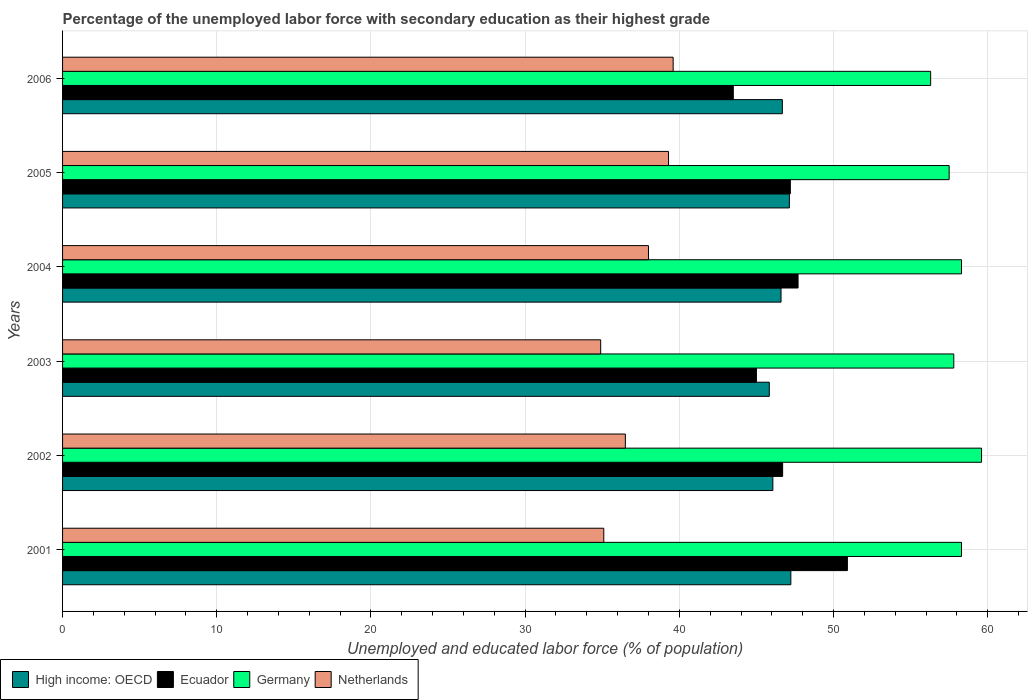How many groups of bars are there?
Offer a very short reply. 6. How many bars are there on the 6th tick from the top?
Your answer should be very brief. 4. What is the label of the 3rd group of bars from the top?
Your answer should be compact. 2004. In how many cases, is the number of bars for a given year not equal to the number of legend labels?
Provide a succinct answer. 0. What is the percentage of the unemployed labor force with secondary education in Ecuador in 2001?
Offer a very short reply. 50.9. Across all years, what is the maximum percentage of the unemployed labor force with secondary education in Netherlands?
Keep it short and to the point. 39.6. Across all years, what is the minimum percentage of the unemployed labor force with secondary education in Germany?
Keep it short and to the point. 56.3. What is the total percentage of the unemployed labor force with secondary education in High income: OECD in the graph?
Keep it short and to the point. 279.55. What is the difference between the percentage of the unemployed labor force with secondary education in Netherlands in 2005 and that in 2006?
Keep it short and to the point. -0.3. What is the difference between the percentage of the unemployed labor force with secondary education in Ecuador in 2004 and the percentage of the unemployed labor force with secondary education in Germany in 2003?
Your response must be concise. -10.1. What is the average percentage of the unemployed labor force with secondary education in High income: OECD per year?
Provide a short and direct response. 46.59. In the year 2003, what is the difference between the percentage of the unemployed labor force with secondary education in Ecuador and percentage of the unemployed labor force with secondary education in High income: OECD?
Your response must be concise. -0.84. In how many years, is the percentage of the unemployed labor force with secondary education in High income: OECD greater than 40 %?
Offer a very short reply. 6. What is the ratio of the percentage of the unemployed labor force with secondary education in Germany in 2001 to that in 2003?
Offer a terse response. 1.01. Is the difference between the percentage of the unemployed labor force with secondary education in Ecuador in 2002 and 2006 greater than the difference between the percentage of the unemployed labor force with secondary education in High income: OECD in 2002 and 2006?
Provide a short and direct response. Yes. What is the difference between the highest and the second highest percentage of the unemployed labor force with secondary education in Netherlands?
Your response must be concise. 0.3. What is the difference between the highest and the lowest percentage of the unemployed labor force with secondary education in Germany?
Offer a very short reply. 3.3. In how many years, is the percentage of the unemployed labor force with secondary education in High income: OECD greater than the average percentage of the unemployed labor force with secondary education in High income: OECD taken over all years?
Provide a succinct answer. 4. Is the sum of the percentage of the unemployed labor force with secondary education in High income: OECD in 2001 and 2005 greater than the maximum percentage of the unemployed labor force with secondary education in Netherlands across all years?
Your response must be concise. Yes. Is it the case that in every year, the sum of the percentage of the unemployed labor force with secondary education in Germany and percentage of the unemployed labor force with secondary education in Ecuador is greater than the sum of percentage of the unemployed labor force with secondary education in Netherlands and percentage of the unemployed labor force with secondary education in High income: OECD?
Ensure brevity in your answer.  Yes. What does the 3rd bar from the top in 2002 represents?
Offer a very short reply. Ecuador. Are all the bars in the graph horizontal?
Your response must be concise. Yes. How many years are there in the graph?
Your response must be concise. 6. Does the graph contain any zero values?
Make the answer very short. No. Where does the legend appear in the graph?
Keep it short and to the point. Bottom left. What is the title of the graph?
Make the answer very short. Percentage of the unemployed labor force with secondary education as their highest grade. What is the label or title of the X-axis?
Provide a short and direct response. Unemployed and educated labor force (% of population). What is the label or title of the Y-axis?
Offer a very short reply. Years. What is the Unemployed and educated labor force (% of population) of High income: OECD in 2001?
Offer a terse response. 47.23. What is the Unemployed and educated labor force (% of population) of Ecuador in 2001?
Offer a terse response. 50.9. What is the Unemployed and educated labor force (% of population) of Germany in 2001?
Keep it short and to the point. 58.3. What is the Unemployed and educated labor force (% of population) of Netherlands in 2001?
Your answer should be compact. 35.1. What is the Unemployed and educated labor force (% of population) in High income: OECD in 2002?
Make the answer very short. 46.07. What is the Unemployed and educated labor force (% of population) in Ecuador in 2002?
Provide a short and direct response. 46.7. What is the Unemployed and educated labor force (% of population) in Germany in 2002?
Your response must be concise. 59.6. What is the Unemployed and educated labor force (% of population) in Netherlands in 2002?
Give a very brief answer. 36.5. What is the Unemployed and educated labor force (% of population) in High income: OECD in 2003?
Ensure brevity in your answer.  45.84. What is the Unemployed and educated labor force (% of population) in Ecuador in 2003?
Provide a succinct answer. 45. What is the Unemployed and educated labor force (% of population) in Germany in 2003?
Offer a terse response. 57.8. What is the Unemployed and educated labor force (% of population) of Netherlands in 2003?
Your answer should be very brief. 34.9. What is the Unemployed and educated labor force (% of population) in High income: OECD in 2004?
Your answer should be very brief. 46.6. What is the Unemployed and educated labor force (% of population) in Ecuador in 2004?
Your answer should be compact. 47.7. What is the Unemployed and educated labor force (% of population) in Germany in 2004?
Your answer should be compact. 58.3. What is the Unemployed and educated labor force (% of population) in Netherlands in 2004?
Offer a very short reply. 38. What is the Unemployed and educated labor force (% of population) of High income: OECD in 2005?
Offer a terse response. 47.14. What is the Unemployed and educated labor force (% of population) in Ecuador in 2005?
Give a very brief answer. 47.2. What is the Unemployed and educated labor force (% of population) in Germany in 2005?
Your response must be concise. 57.5. What is the Unemployed and educated labor force (% of population) in Netherlands in 2005?
Keep it short and to the point. 39.3. What is the Unemployed and educated labor force (% of population) of High income: OECD in 2006?
Your answer should be compact. 46.68. What is the Unemployed and educated labor force (% of population) in Ecuador in 2006?
Ensure brevity in your answer.  43.5. What is the Unemployed and educated labor force (% of population) in Germany in 2006?
Give a very brief answer. 56.3. What is the Unemployed and educated labor force (% of population) of Netherlands in 2006?
Provide a short and direct response. 39.6. Across all years, what is the maximum Unemployed and educated labor force (% of population) of High income: OECD?
Give a very brief answer. 47.23. Across all years, what is the maximum Unemployed and educated labor force (% of population) in Ecuador?
Offer a very short reply. 50.9. Across all years, what is the maximum Unemployed and educated labor force (% of population) of Germany?
Provide a short and direct response. 59.6. Across all years, what is the maximum Unemployed and educated labor force (% of population) in Netherlands?
Provide a short and direct response. 39.6. Across all years, what is the minimum Unemployed and educated labor force (% of population) of High income: OECD?
Ensure brevity in your answer.  45.84. Across all years, what is the minimum Unemployed and educated labor force (% of population) of Ecuador?
Your answer should be compact. 43.5. Across all years, what is the minimum Unemployed and educated labor force (% of population) in Germany?
Make the answer very short. 56.3. Across all years, what is the minimum Unemployed and educated labor force (% of population) in Netherlands?
Ensure brevity in your answer.  34.9. What is the total Unemployed and educated labor force (% of population) of High income: OECD in the graph?
Your response must be concise. 279.55. What is the total Unemployed and educated labor force (% of population) of Ecuador in the graph?
Your response must be concise. 281. What is the total Unemployed and educated labor force (% of population) in Germany in the graph?
Keep it short and to the point. 347.8. What is the total Unemployed and educated labor force (% of population) in Netherlands in the graph?
Your response must be concise. 223.4. What is the difference between the Unemployed and educated labor force (% of population) of High income: OECD in 2001 and that in 2002?
Offer a very short reply. 1.17. What is the difference between the Unemployed and educated labor force (% of population) in Germany in 2001 and that in 2002?
Your answer should be compact. -1.3. What is the difference between the Unemployed and educated labor force (% of population) of High income: OECD in 2001 and that in 2003?
Keep it short and to the point. 1.4. What is the difference between the Unemployed and educated labor force (% of population) of Germany in 2001 and that in 2003?
Provide a short and direct response. 0.5. What is the difference between the Unemployed and educated labor force (% of population) of High income: OECD in 2001 and that in 2004?
Ensure brevity in your answer.  0.64. What is the difference between the Unemployed and educated labor force (% of population) of Netherlands in 2001 and that in 2004?
Provide a short and direct response. -2.9. What is the difference between the Unemployed and educated labor force (% of population) in High income: OECD in 2001 and that in 2005?
Provide a succinct answer. 0.1. What is the difference between the Unemployed and educated labor force (% of population) of Netherlands in 2001 and that in 2005?
Give a very brief answer. -4.2. What is the difference between the Unemployed and educated labor force (% of population) in High income: OECD in 2001 and that in 2006?
Ensure brevity in your answer.  0.55. What is the difference between the Unemployed and educated labor force (% of population) of Germany in 2001 and that in 2006?
Offer a very short reply. 2. What is the difference between the Unemployed and educated labor force (% of population) in High income: OECD in 2002 and that in 2003?
Offer a terse response. 0.23. What is the difference between the Unemployed and educated labor force (% of population) of High income: OECD in 2002 and that in 2004?
Give a very brief answer. -0.53. What is the difference between the Unemployed and educated labor force (% of population) of Germany in 2002 and that in 2004?
Keep it short and to the point. 1.3. What is the difference between the Unemployed and educated labor force (% of population) of Netherlands in 2002 and that in 2004?
Your response must be concise. -1.5. What is the difference between the Unemployed and educated labor force (% of population) of High income: OECD in 2002 and that in 2005?
Provide a short and direct response. -1.07. What is the difference between the Unemployed and educated labor force (% of population) in Ecuador in 2002 and that in 2005?
Make the answer very short. -0.5. What is the difference between the Unemployed and educated labor force (% of population) in Germany in 2002 and that in 2005?
Give a very brief answer. 2.1. What is the difference between the Unemployed and educated labor force (% of population) in Netherlands in 2002 and that in 2005?
Offer a terse response. -2.8. What is the difference between the Unemployed and educated labor force (% of population) in High income: OECD in 2002 and that in 2006?
Your answer should be very brief. -0.62. What is the difference between the Unemployed and educated labor force (% of population) of Ecuador in 2002 and that in 2006?
Your response must be concise. 3.2. What is the difference between the Unemployed and educated labor force (% of population) in High income: OECD in 2003 and that in 2004?
Offer a terse response. -0.76. What is the difference between the Unemployed and educated labor force (% of population) in Germany in 2003 and that in 2004?
Provide a succinct answer. -0.5. What is the difference between the Unemployed and educated labor force (% of population) in High income: OECD in 2003 and that in 2005?
Provide a succinct answer. -1.3. What is the difference between the Unemployed and educated labor force (% of population) in Ecuador in 2003 and that in 2005?
Provide a succinct answer. -2.2. What is the difference between the Unemployed and educated labor force (% of population) of Germany in 2003 and that in 2005?
Provide a short and direct response. 0.3. What is the difference between the Unemployed and educated labor force (% of population) of High income: OECD in 2003 and that in 2006?
Keep it short and to the point. -0.85. What is the difference between the Unemployed and educated labor force (% of population) in Netherlands in 2003 and that in 2006?
Your answer should be compact. -4.7. What is the difference between the Unemployed and educated labor force (% of population) in High income: OECD in 2004 and that in 2005?
Offer a very short reply. -0.54. What is the difference between the Unemployed and educated labor force (% of population) of Netherlands in 2004 and that in 2005?
Provide a succinct answer. -1.3. What is the difference between the Unemployed and educated labor force (% of population) in High income: OECD in 2004 and that in 2006?
Provide a short and direct response. -0.09. What is the difference between the Unemployed and educated labor force (% of population) of Netherlands in 2004 and that in 2006?
Offer a very short reply. -1.6. What is the difference between the Unemployed and educated labor force (% of population) in High income: OECD in 2005 and that in 2006?
Your response must be concise. 0.46. What is the difference between the Unemployed and educated labor force (% of population) of Ecuador in 2005 and that in 2006?
Offer a very short reply. 3.7. What is the difference between the Unemployed and educated labor force (% of population) of Germany in 2005 and that in 2006?
Ensure brevity in your answer.  1.2. What is the difference between the Unemployed and educated labor force (% of population) in Netherlands in 2005 and that in 2006?
Your answer should be very brief. -0.3. What is the difference between the Unemployed and educated labor force (% of population) of High income: OECD in 2001 and the Unemployed and educated labor force (% of population) of Ecuador in 2002?
Give a very brief answer. 0.53. What is the difference between the Unemployed and educated labor force (% of population) of High income: OECD in 2001 and the Unemployed and educated labor force (% of population) of Germany in 2002?
Your response must be concise. -12.37. What is the difference between the Unemployed and educated labor force (% of population) in High income: OECD in 2001 and the Unemployed and educated labor force (% of population) in Netherlands in 2002?
Provide a short and direct response. 10.73. What is the difference between the Unemployed and educated labor force (% of population) in Ecuador in 2001 and the Unemployed and educated labor force (% of population) in Germany in 2002?
Provide a succinct answer. -8.7. What is the difference between the Unemployed and educated labor force (% of population) of Ecuador in 2001 and the Unemployed and educated labor force (% of population) of Netherlands in 2002?
Your answer should be compact. 14.4. What is the difference between the Unemployed and educated labor force (% of population) in Germany in 2001 and the Unemployed and educated labor force (% of population) in Netherlands in 2002?
Your response must be concise. 21.8. What is the difference between the Unemployed and educated labor force (% of population) of High income: OECD in 2001 and the Unemployed and educated labor force (% of population) of Ecuador in 2003?
Make the answer very short. 2.23. What is the difference between the Unemployed and educated labor force (% of population) of High income: OECD in 2001 and the Unemployed and educated labor force (% of population) of Germany in 2003?
Offer a very short reply. -10.57. What is the difference between the Unemployed and educated labor force (% of population) of High income: OECD in 2001 and the Unemployed and educated labor force (% of population) of Netherlands in 2003?
Make the answer very short. 12.33. What is the difference between the Unemployed and educated labor force (% of population) of Germany in 2001 and the Unemployed and educated labor force (% of population) of Netherlands in 2003?
Your answer should be compact. 23.4. What is the difference between the Unemployed and educated labor force (% of population) of High income: OECD in 2001 and the Unemployed and educated labor force (% of population) of Ecuador in 2004?
Your answer should be very brief. -0.47. What is the difference between the Unemployed and educated labor force (% of population) in High income: OECD in 2001 and the Unemployed and educated labor force (% of population) in Germany in 2004?
Give a very brief answer. -11.07. What is the difference between the Unemployed and educated labor force (% of population) in High income: OECD in 2001 and the Unemployed and educated labor force (% of population) in Netherlands in 2004?
Offer a very short reply. 9.23. What is the difference between the Unemployed and educated labor force (% of population) in Ecuador in 2001 and the Unemployed and educated labor force (% of population) in Netherlands in 2004?
Your answer should be compact. 12.9. What is the difference between the Unemployed and educated labor force (% of population) of Germany in 2001 and the Unemployed and educated labor force (% of population) of Netherlands in 2004?
Ensure brevity in your answer.  20.3. What is the difference between the Unemployed and educated labor force (% of population) of High income: OECD in 2001 and the Unemployed and educated labor force (% of population) of Ecuador in 2005?
Provide a short and direct response. 0.03. What is the difference between the Unemployed and educated labor force (% of population) of High income: OECD in 2001 and the Unemployed and educated labor force (% of population) of Germany in 2005?
Make the answer very short. -10.27. What is the difference between the Unemployed and educated labor force (% of population) of High income: OECD in 2001 and the Unemployed and educated labor force (% of population) of Netherlands in 2005?
Provide a short and direct response. 7.93. What is the difference between the Unemployed and educated labor force (% of population) of Ecuador in 2001 and the Unemployed and educated labor force (% of population) of Netherlands in 2005?
Your answer should be compact. 11.6. What is the difference between the Unemployed and educated labor force (% of population) of Germany in 2001 and the Unemployed and educated labor force (% of population) of Netherlands in 2005?
Your answer should be very brief. 19. What is the difference between the Unemployed and educated labor force (% of population) of High income: OECD in 2001 and the Unemployed and educated labor force (% of population) of Ecuador in 2006?
Offer a very short reply. 3.73. What is the difference between the Unemployed and educated labor force (% of population) in High income: OECD in 2001 and the Unemployed and educated labor force (% of population) in Germany in 2006?
Your answer should be very brief. -9.07. What is the difference between the Unemployed and educated labor force (% of population) of High income: OECD in 2001 and the Unemployed and educated labor force (% of population) of Netherlands in 2006?
Provide a short and direct response. 7.63. What is the difference between the Unemployed and educated labor force (% of population) in Ecuador in 2001 and the Unemployed and educated labor force (% of population) in Netherlands in 2006?
Ensure brevity in your answer.  11.3. What is the difference between the Unemployed and educated labor force (% of population) in High income: OECD in 2002 and the Unemployed and educated labor force (% of population) in Ecuador in 2003?
Provide a short and direct response. 1.07. What is the difference between the Unemployed and educated labor force (% of population) of High income: OECD in 2002 and the Unemployed and educated labor force (% of population) of Germany in 2003?
Your answer should be very brief. -11.73. What is the difference between the Unemployed and educated labor force (% of population) of High income: OECD in 2002 and the Unemployed and educated labor force (% of population) of Netherlands in 2003?
Ensure brevity in your answer.  11.17. What is the difference between the Unemployed and educated labor force (% of population) of Germany in 2002 and the Unemployed and educated labor force (% of population) of Netherlands in 2003?
Ensure brevity in your answer.  24.7. What is the difference between the Unemployed and educated labor force (% of population) in High income: OECD in 2002 and the Unemployed and educated labor force (% of population) in Ecuador in 2004?
Provide a short and direct response. -1.63. What is the difference between the Unemployed and educated labor force (% of population) in High income: OECD in 2002 and the Unemployed and educated labor force (% of population) in Germany in 2004?
Your answer should be compact. -12.23. What is the difference between the Unemployed and educated labor force (% of population) of High income: OECD in 2002 and the Unemployed and educated labor force (% of population) of Netherlands in 2004?
Offer a terse response. 8.07. What is the difference between the Unemployed and educated labor force (% of population) in Ecuador in 2002 and the Unemployed and educated labor force (% of population) in Germany in 2004?
Provide a short and direct response. -11.6. What is the difference between the Unemployed and educated labor force (% of population) of Ecuador in 2002 and the Unemployed and educated labor force (% of population) of Netherlands in 2004?
Your answer should be very brief. 8.7. What is the difference between the Unemployed and educated labor force (% of population) in Germany in 2002 and the Unemployed and educated labor force (% of population) in Netherlands in 2004?
Make the answer very short. 21.6. What is the difference between the Unemployed and educated labor force (% of population) of High income: OECD in 2002 and the Unemployed and educated labor force (% of population) of Ecuador in 2005?
Offer a very short reply. -1.13. What is the difference between the Unemployed and educated labor force (% of population) in High income: OECD in 2002 and the Unemployed and educated labor force (% of population) in Germany in 2005?
Provide a short and direct response. -11.43. What is the difference between the Unemployed and educated labor force (% of population) in High income: OECD in 2002 and the Unemployed and educated labor force (% of population) in Netherlands in 2005?
Your response must be concise. 6.77. What is the difference between the Unemployed and educated labor force (% of population) of Germany in 2002 and the Unemployed and educated labor force (% of population) of Netherlands in 2005?
Ensure brevity in your answer.  20.3. What is the difference between the Unemployed and educated labor force (% of population) in High income: OECD in 2002 and the Unemployed and educated labor force (% of population) in Ecuador in 2006?
Offer a very short reply. 2.57. What is the difference between the Unemployed and educated labor force (% of population) in High income: OECD in 2002 and the Unemployed and educated labor force (% of population) in Germany in 2006?
Keep it short and to the point. -10.23. What is the difference between the Unemployed and educated labor force (% of population) in High income: OECD in 2002 and the Unemployed and educated labor force (% of population) in Netherlands in 2006?
Give a very brief answer. 6.47. What is the difference between the Unemployed and educated labor force (% of population) of Ecuador in 2002 and the Unemployed and educated labor force (% of population) of Netherlands in 2006?
Your answer should be very brief. 7.1. What is the difference between the Unemployed and educated labor force (% of population) in High income: OECD in 2003 and the Unemployed and educated labor force (% of population) in Ecuador in 2004?
Give a very brief answer. -1.86. What is the difference between the Unemployed and educated labor force (% of population) of High income: OECD in 2003 and the Unemployed and educated labor force (% of population) of Germany in 2004?
Offer a very short reply. -12.46. What is the difference between the Unemployed and educated labor force (% of population) of High income: OECD in 2003 and the Unemployed and educated labor force (% of population) of Netherlands in 2004?
Provide a short and direct response. 7.84. What is the difference between the Unemployed and educated labor force (% of population) in Ecuador in 2003 and the Unemployed and educated labor force (% of population) in Netherlands in 2004?
Offer a terse response. 7. What is the difference between the Unemployed and educated labor force (% of population) of Germany in 2003 and the Unemployed and educated labor force (% of population) of Netherlands in 2004?
Offer a terse response. 19.8. What is the difference between the Unemployed and educated labor force (% of population) in High income: OECD in 2003 and the Unemployed and educated labor force (% of population) in Ecuador in 2005?
Your answer should be compact. -1.36. What is the difference between the Unemployed and educated labor force (% of population) in High income: OECD in 2003 and the Unemployed and educated labor force (% of population) in Germany in 2005?
Make the answer very short. -11.66. What is the difference between the Unemployed and educated labor force (% of population) in High income: OECD in 2003 and the Unemployed and educated labor force (% of population) in Netherlands in 2005?
Provide a short and direct response. 6.54. What is the difference between the Unemployed and educated labor force (% of population) of Ecuador in 2003 and the Unemployed and educated labor force (% of population) of Germany in 2005?
Offer a terse response. -12.5. What is the difference between the Unemployed and educated labor force (% of population) of High income: OECD in 2003 and the Unemployed and educated labor force (% of population) of Ecuador in 2006?
Provide a succinct answer. 2.34. What is the difference between the Unemployed and educated labor force (% of population) in High income: OECD in 2003 and the Unemployed and educated labor force (% of population) in Germany in 2006?
Provide a short and direct response. -10.46. What is the difference between the Unemployed and educated labor force (% of population) in High income: OECD in 2003 and the Unemployed and educated labor force (% of population) in Netherlands in 2006?
Give a very brief answer. 6.24. What is the difference between the Unemployed and educated labor force (% of population) in Ecuador in 2003 and the Unemployed and educated labor force (% of population) in Germany in 2006?
Provide a succinct answer. -11.3. What is the difference between the Unemployed and educated labor force (% of population) in Germany in 2003 and the Unemployed and educated labor force (% of population) in Netherlands in 2006?
Offer a very short reply. 18.2. What is the difference between the Unemployed and educated labor force (% of population) in High income: OECD in 2004 and the Unemployed and educated labor force (% of population) in Ecuador in 2005?
Provide a succinct answer. -0.6. What is the difference between the Unemployed and educated labor force (% of population) of High income: OECD in 2004 and the Unemployed and educated labor force (% of population) of Germany in 2005?
Your response must be concise. -10.9. What is the difference between the Unemployed and educated labor force (% of population) of High income: OECD in 2004 and the Unemployed and educated labor force (% of population) of Netherlands in 2005?
Give a very brief answer. 7.3. What is the difference between the Unemployed and educated labor force (% of population) of Ecuador in 2004 and the Unemployed and educated labor force (% of population) of Netherlands in 2005?
Provide a succinct answer. 8.4. What is the difference between the Unemployed and educated labor force (% of population) in Germany in 2004 and the Unemployed and educated labor force (% of population) in Netherlands in 2005?
Give a very brief answer. 19. What is the difference between the Unemployed and educated labor force (% of population) in High income: OECD in 2004 and the Unemployed and educated labor force (% of population) in Ecuador in 2006?
Your response must be concise. 3.1. What is the difference between the Unemployed and educated labor force (% of population) of High income: OECD in 2004 and the Unemployed and educated labor force (% of population) of Germany in 2006?
Your answer should be very brief. -9.7. What is the difference between the Unemployed and educated labor force (% of population) of High income: OECD in 2004 and the Unemployed and educated labor force (% of population) of Netherlands in 2006?
Make the answer very short. 7. What is the difference between the Unemployed and educated labor force (% of population) in Ecuador in 2004 and the Unemployed and educated labor force (% of population) in Germany in 2006?
Offer a very short reply. -8.6. What is the difference between the Unemployed and educated labor force (% of population) of Ecuador in 2004 and the Unemployed and educated labor force (% of population) of Netherlands in 2006?
Make the answer very short. 8.1. What is the difference between the Unemployed and educated labor force (% of population) of Germany in 2004 and the Unemployed and educated labor force (% of population) of Netherlands in 2006?
Keep it short and to the point. 18.7. What is the difference between the Unemployed and educated labor force (% of population) of High income: OECD in 2005 and the Unemployed and educated labor force (% of population) of Ecuador in 2006?
Offer a terse response. 3.64. What is the difference between the Unemployed and educated labor force (% of population) of High income: OECD in 2005 and the Unemployed and educated labor force (% of population) of Germany in 2006?
Keep it short and to the point. -9.16. What is the difference between the Unemployed and educated labor force (% of population) of High income: OECD in 2005 and the Unemployed and educated labor force (% of population) of Netherlands in 2006?
Your response must be concise. 7.54. What is the average Unemployed and educated labor force (% of population) in High income: OECD per year?
Give a very brief answer. 46.59. What is the average Unemployed and educated labor force (% of population) of Ecuador per year?
Your answer should be very brief. 46.83. What is the average Unemployed and educated labor force (% of population) of Germany per year?
Keep it short and to the point. 57.97. What is the average Unemployed and educated labor force (% of population) in Netherlands per year?
Your answer should be very brief. 37.23. In the year 2001, what is the difference between the Unemployed and educated labor force (% of population) in High income: OECD and Unemployed and educated labor force (% of population) in Ecuador?
Your answer should be very brief. -3.67. In the year 2001, what is the difference between the Unemployed and educated labor force (% of population) of High income: OECD and Unemployed and educated labor force (% of population) of Germany?
Your response must be concise. -11.07. In the year 2001, what is the difference between the Unemployed and educated labor force (% of population) in High income: OECD and Unemployed and educated labor force (% of population) in Netherlands?
Your answer should be compact. 12.13. In the year 2001, what is the difference between the Unemployed and educated labor force (% of population) in Germany and Unemployed and educated labor force (% of population) in Netherlands?
Make the answer very short. 23.2. In the year 2002, what is the difference between the Unemployed and educated labor force (% of population) in High income: OECD and Unemployed and educated labor force (% of population) in Ecuador?
Give a very brief answer. -0.63. In the year 2002, what is the difference between the Unemployed and educated labor force (% of population) in High income: OECD and Unemployed and educated labor force (% of population) in Germany?
Your answer should be very brief. -13.53. In the year 2002, what is the difference between the Unemployed and educated labor force (% of population) of High income: OECD and Unemployed and educated labor force (% of population) of Netherlands?
Your answer should be compact. 9.57. In the year 2002, what is the difference between the Unemployed and educated labor force (% of population) of Ecuador and Unemployed and educated labor force (% of population) of Netherlands?
Your answer should be compact. 10.2. In the year 2002, what is the difference between the Unemployed and educated labor force (% of population) of Germany and Unemployed and educated labor force (% of population) of Netherlands?
Offer a terse response. 23.1. In the year 2003, what is the difference between the Unemployed and educated labor force (% of population) of High income: OECD and Unemployed and educated labor force (% of population) of Ecuador?
Provide a short and direct response. 0.84. In the year 2003, what is the difference between the Unemployed and educated labor force (% of population) in High income: OECD and Unemployed and educated labor force (% of population) in Germany?
Offer a terse response. -11.96. In the year 2003, what is the difference between the Unemployed and educated labor force (% of population) in High income: OECD and Unemployed and educated labor force (% of population) in Netherlands?
Provide a short and direct response. 10.94. In the year 2003, what is the difference between the Unemployed and educated labor force (% of population) of Ecuador and Unemployed and educated labor force (% of population) of Netherlands?
Make the answer very short. 10.1. In the year 2003, what is the difference between the Unemployed and educated labor force (% of population) in Germany and Unemployed and educated labor force (% of population) in Netherlands?
Ensure brevity in your answer.  22.9. In the year 2004, what is the difference between the Unemployed and educated labor force (% of population) of High income: OECD and Unemployed and educated labor force (% of population) of Ecuador?
Provide a short and direct response. -1.1. In the year 2004, what is the difference between the Unemployed and educated labor force (% of population) of High income: OECD and Unemployed and educated labor force (% of population) of Germany?
Offer a terse response. -11.7. In the year 2004, what is the difference between the Unemployed and educated labor force (% of population) of High income: OECD and Unemployed and educated labor force (% of population) of Netherlands?
Your answer should be very brief. 8.6. In the year 2004, what is the difference between the Unemployed and educated labor force (% of population) in Ecuador and Unemployed and educated labor force (% of population) in Netherlands?
Keep it short and to the point. 9.7. In the year 2004, what is the difference between the Unemployed and educated labor force (% of population) of Germany and Unemployed and educated labor force (% of population) of Netherlands?
Give a very brief answer. 20.3. In the year 2005, what is the difference between the Unemployed and educated labor force (% of population) of High income: OECD and Unemployed and educated labor force (% of population) of Ecuador?
Provide a succinct answer. -0.06. In the year 2005, what is the difference between the Unemployed and educated labor force (% of population) of High income: OECD and Unemployed and educated labor force (% of population) of Germany?
Your answer should be compact. -10.36. In the year 2005, what is the difference between the Unemployed and educated labor force (% of population) in High income: OECD and Unemployed and educated labor force (% of population) in Netherlands?
Ensure brevity in your answer.  7.84. In the year 2005, what is the difference between the Unemployed and educated labor force (% of population) of Ecuador and Unemployed and educated labor force (% of population) of Netherlands?
Give a very brief answer. 7.9. In the year 2005, what is the difference between the Unemployed and educated labor force (% of population) of Germany and Unemployed and educated labor force (% of population) of Netherlands?
Offer a very short reply. 18.2. In the year 2006, what is the difference between the Unemployed and educated labor force (% of population) in High income: OECD and Unemployed and educated labor force (% of population) in Ecuador?
Your response must be concise. 3.18. In the year 2006, what is the difference between the Unemployed and educated labor force (% of population) of High income: OECD and Unemployed and educated labor force (% of population) of Germany?
Make the answer very short. -9.62. In the year 2006, what is the difference between the Unemployed and educated labor force (% of population) in High income: OECD and Unemployed and educated labor force (% of population) in Netherlands?
Offer a very short reply. 7.08. In the year 2006, what is the difference between the Unemployed and educated labor force (% of population) of Ecuador and Unemployed and educated labor force (% of population) of Germany?
Make the answer very short. -12.8. In the year 2006, what is the difference between the Unemployed and educated labor force (% of population) of Ecuador and Unemployed and educated labor force (% of population) of Netherlands?
Keep it short and to the point. 3.9. In the year 2006, what is the difference between the Unemployed and educated labor force (% of population) of Germany and Unemployed and educated labor force (% of population) of Netherlands?
Offer a very short reply. 16.7. What is the ratio of the Unemployed and educated labor force (% of population) of High income: OECD in 2001 to that in 2002?
Your response must be concise. 1.03. What is the ratio of the Unemployed and educated labor force (% of population) in Ecuador in 2001 to that in 2002?
Provide a short and direct response. 1.09. What is the ratio of the Unemployed and educated labor force (% of population) of Germany in 2001 to that in 2002?
Your answer should be compact. 0.98. What is the ratio of the Unemployed and educated labor force (% of population) in Netherlands in 2001 to that in 2002?
Your answer should be compact. 0.96. What is the ratio of the Unemployed and educated labor force (% of population) of High income: OECD in 2001 to that in 2003?
Keep it short and to the point. 1.03. What is the ratio of the Unemployed and educated labor force (% of population) of Ecuador in 2001 to that in 2003?
Provide a short and direct response. 1.13. What is the ratio of the Unemployed and educated labor force (% of population) in Germany in 2001 to that in 2003?
Ensure brevity in your answer.  1.01. What is the ratio of the Unemployed and educated labor force (% of population) of Netherlands in 2001 to that in 2003?
Give a very brief answer. 1.01. What is the ratio of the Unemployed and educated labor force (% of population) of High income: OECD in 2001 to that in 2004?
Offer a very short reply. 1.01. What is the ratio of the Unemployed and educated labor force (% of population) of Ecuador in 2001 to that in 2004?
Offer a very short reply. 1.07. What is the ratio of the Unemployed and educated labor force (% of population) of Netherlands in 2001 to that in 2004?
Keep it short and to the point. 0.92. What is the ratio of the Unemployed and educated labor force (% of population) of High income: OECD in 2001 to that in 2005?
Provide a succinct answer. 1. What is the ratio of the Unemployed and educated labor force (% of population) of Ecuador in 2001 to that in 2005?
Offer a terse response. 1.08. What is the ratio of the Unemployed and educated labor force (% of population) in Germany in 2001 to that in 2005?
Offer a very short reply. 1.01. What is the ratio of the Unemployed and educated labor force (% of population) in Netherlands in 2001 to that in 2005?
Provide a short and direct response. 0.89. What is the ratio of the Unemployed and educated labor force (% of population) of High income: OECD in 2001 to that in 2006?
Give a very brief answer. 1.01. What is the ratio of the Unemployed and educated labor force (% of population) in Ecuador in 2001 to that in 2006?
Your answer should be very brief. 1.17. What is the ratio of the Unemployed and educated labor force (% of population) of Germany in 2001 to that in 2006?
Offer a very short reply. 1.04. What is the ratio of the Unemployed and educated labor force (% of population) of Netherlands in 2001 to that in 2006?
Give a very brief answer. 0.89. What is the ratio of the Unemployed and educated labor force (% of population) in Ecuador in 2002 to that in 2003?
Provide a succinct answer. 1.04. What is the ratio of the Unemployed and educated labor force (% of population) in Germany in 2002 to that in 2003?
Provide a short and direct response. 1.03. What is the ratio of the Unemployed and educated labor force (% of population) of Netherlands in 2002 to that in 2003?
Make the answer very short. 1.05. What is the ratio of the Unemployed and educated labor force (% of population) in Germany in 2002 to that in 2004?
Give a very brief answer. 1.02. What is the ratio of the Unemployed and educated labor force (% of population) in Netherlands in 2002 to that in 2004?
Offer a terse response. 0.96. What is the ratio of the Unemployed and educated labor force (% of population) of High income: OECD in 2002 to that in 2005?
Offer a terse response. 0.98. What is the ratio of the Unemployed and educated labor force (% of population) in Germany in 2002 to that in 2005?
Provide a short and direct response. 1.04. What is the ratio of the Unemployed and educated labor force (% of population) in Netherlands in 2002 to that in 2005?
Make the answer very short. 0.93. What is the ratio of the Unemployed and educated labor force (% of population) in High income: OECD in 2002 to that in 2006?
Provide a short and direct response. 0.99. What is the ratio of the Unemployed and educated labor force (% of population) in Ecuador in 2002 to that in 2006?
Give a very brief answer. 1.07. What is the ratio of the Unemployed and educated labor force (% of population) in Germany in 2002 to that in 2006?
Your answer should be compact. 1.06. What is the ratio of the Unemployed and educated labor force (% of population) of Netherlands in 2002 to that in 2006?
Offer a terse response. 0.92. What is the ratio of the Unemployed and educated labor force (% of population) in High income: OECD in 2003 to that in 2004?
Your response must be concise. 0.98. What is the ratio of the Unemployed and educated labor force (% of population) of Ecuador in 2003 to that in 2004?
Your answer should be compact. 0.94. What is the ratio of the Unemployed and educated labor force (% of population) in Germany in 2003 to that in 2004?
Provide a short and direct response. 0.99. What is the ratio of the Unemployed and educated labor force (% of population) in Netherlands in 2003 to that in 2004?
Provide a short and direct response. 0.92. What is the ratio of the Unemployed and educated labor force (% of population) in High income: OECD in 2003 to that in 2005?
Offer a very short reply. 0.97. What is the ratio of the Unemployed and educated labor force (% of population) of Ecuador in 2003 to that in 2005?
Your response must be concise. 0.95. What is the ratio of the Unemployed and educated labor force (% of population) in Germany in 2003 to that in 2005?
Your response must be concise. 1.01. What is the ratio of the Unemployed and educated labor force (% of population) of Netherlands in 2003 to that in 2005?
Keep it short and to the point. 0.89. What is the ratio of the Unemployed and educated labor force (% of population) of High income: OECD in 2003 to that in 2006?
Give a very brief answer. 0.98. What is the ratio of the Unemployed and educated labor force (% of population) in Ecuador in 2003 to that in 2006?
Your response must be concise. 1.03. What is the ratio of the Unemployed and educated labor force (% of population) of Germany in 2003 to that in 2006?
Your answer should be very brief. 1.03. What is the ratio of the Unemployed and educated labor force (% of population) of Netherlands in 2003 to that in 2006?
Offer a terse response. 0.88. What is the ratio of the Unemployed and educated labor force (% of population) in High income: OECD in 2004 to that in 2005?
Provide a succinct answer. 0.99. What is the ratio of the Unemployed and educated labor force (% of population) in Ecuador in 2004 to that in 2005?
Your answer should be very brief. 1.01. What is the ratio of the Unemployed and educated labor force (% of population) in Germany in 2004 to that in 2005?
Your answer should be very brief. 1.01. What is the ratio of the Unemployed and educated labor force (% of population) of Netherlands in 2004 to that in 2005?
Provide a succinct answer. 0.97. What is the ratio of the Unemployed and educated labor force (% of population) of High income: OECD in 2004 to that in 2006?
Your response must be concise. 1. What is the ratio of the Unemployed and educated labor force (% of population) of Ecuador in 2004 to that in 2006?
Make the answer very short. 1.1. What is the ratio of the Unemployed and educated labor force (% of population) of Germany in 2004 to that in 2006?
Offer a very short reply. 1.04. What is the ratio of the Unemployed and educated labor force (% of population) in Netherlands in 2004 to that in 2006?
Your answer should be very brief. 0.96. What is the ratio of the Unemployed and educated labor force (% of population) of High income: OECD in 2005 to that in 2006?
Give a very brief answer. 1.01. What is the ratio of the Unemployed and educated labor force (% of population) of Ecuador in 2005 to that in 2006?
Your answer should be compact. 1.09. What is the ratio of the Unemployed and educated labor force (% of population) in Germany in 2005 to that in 2006?
Give a very brief answer. 1.02. What is the ratio of the Unemployed and educated labor force (% of population) in Netherlands in 2005 to that in 2006?
Give a very brief answer. 0.99. What is the difference between the highest and the second highest Unemployed and educated labor force (% of population) in High income: OECD?
Provide a short and direct response. 0.1. What is the difference between the highest and the second highest Unemployed and educated labor force (% of population) of Ecuador?
Your response must be concise. 3.2. What is the difference between the highest and the second highest Unemployed and educated labor force (% of population) of Netherlands?
Keep it short and to the point. 0.3. What is the difference between the highest and the lowest Unemployed and educated labor force (% of population) in High income: OECD?
Provide a succinct answer. 1.4. What is the difference between the highest and the lowest Unemployed and educated labor force (% of population) of Germany?
Offer a very short reply. 3.3. What is the difference between the highest and the lowest Unemployed and educated labor force (% of population) of Netherlands?
Your answer should be very brief. 4.7. 